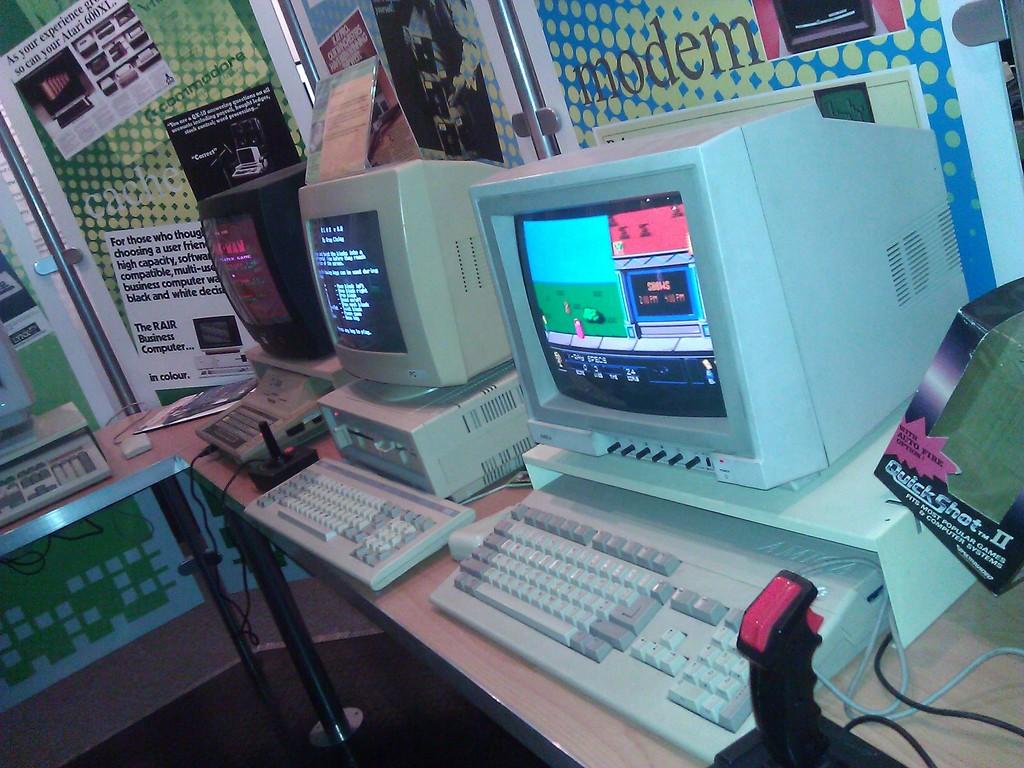What is printed on the box on the right?
Offer a terse response. Quick shot. 